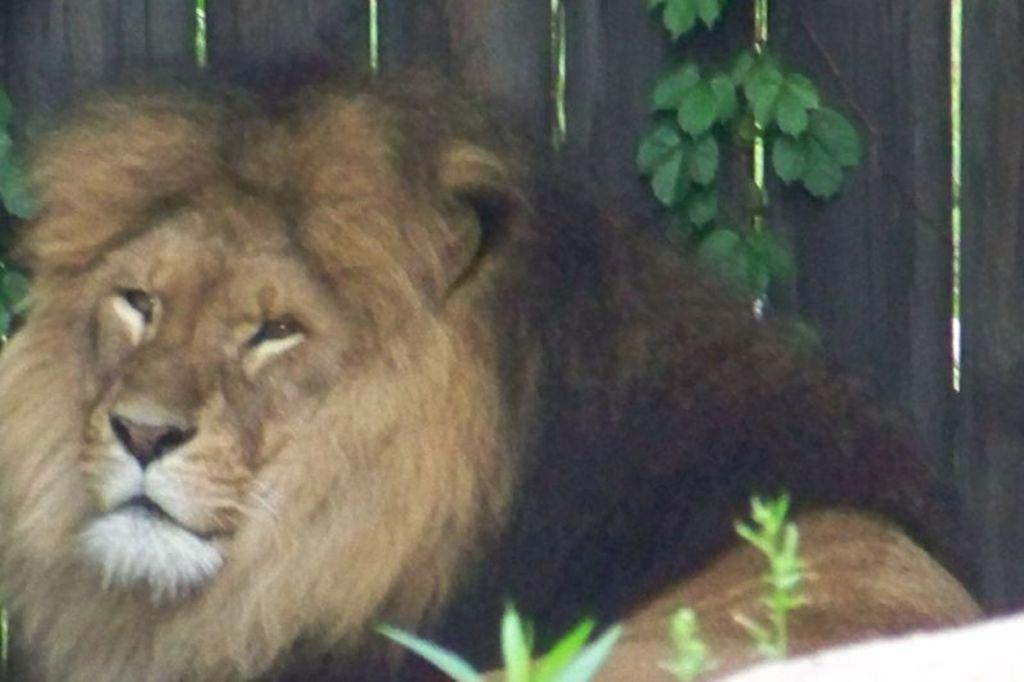What animal is present in the image? There is a lion in the image. What type of vegetation can be seen in the image? There are plants in the image. What can be seen in the background of the image? There is a wooden fence in the background of the image. What type of weather is depicted in the image? The image does not depict any specific weather conditions, as there is no mention of rain, snow, or other weather elements. 